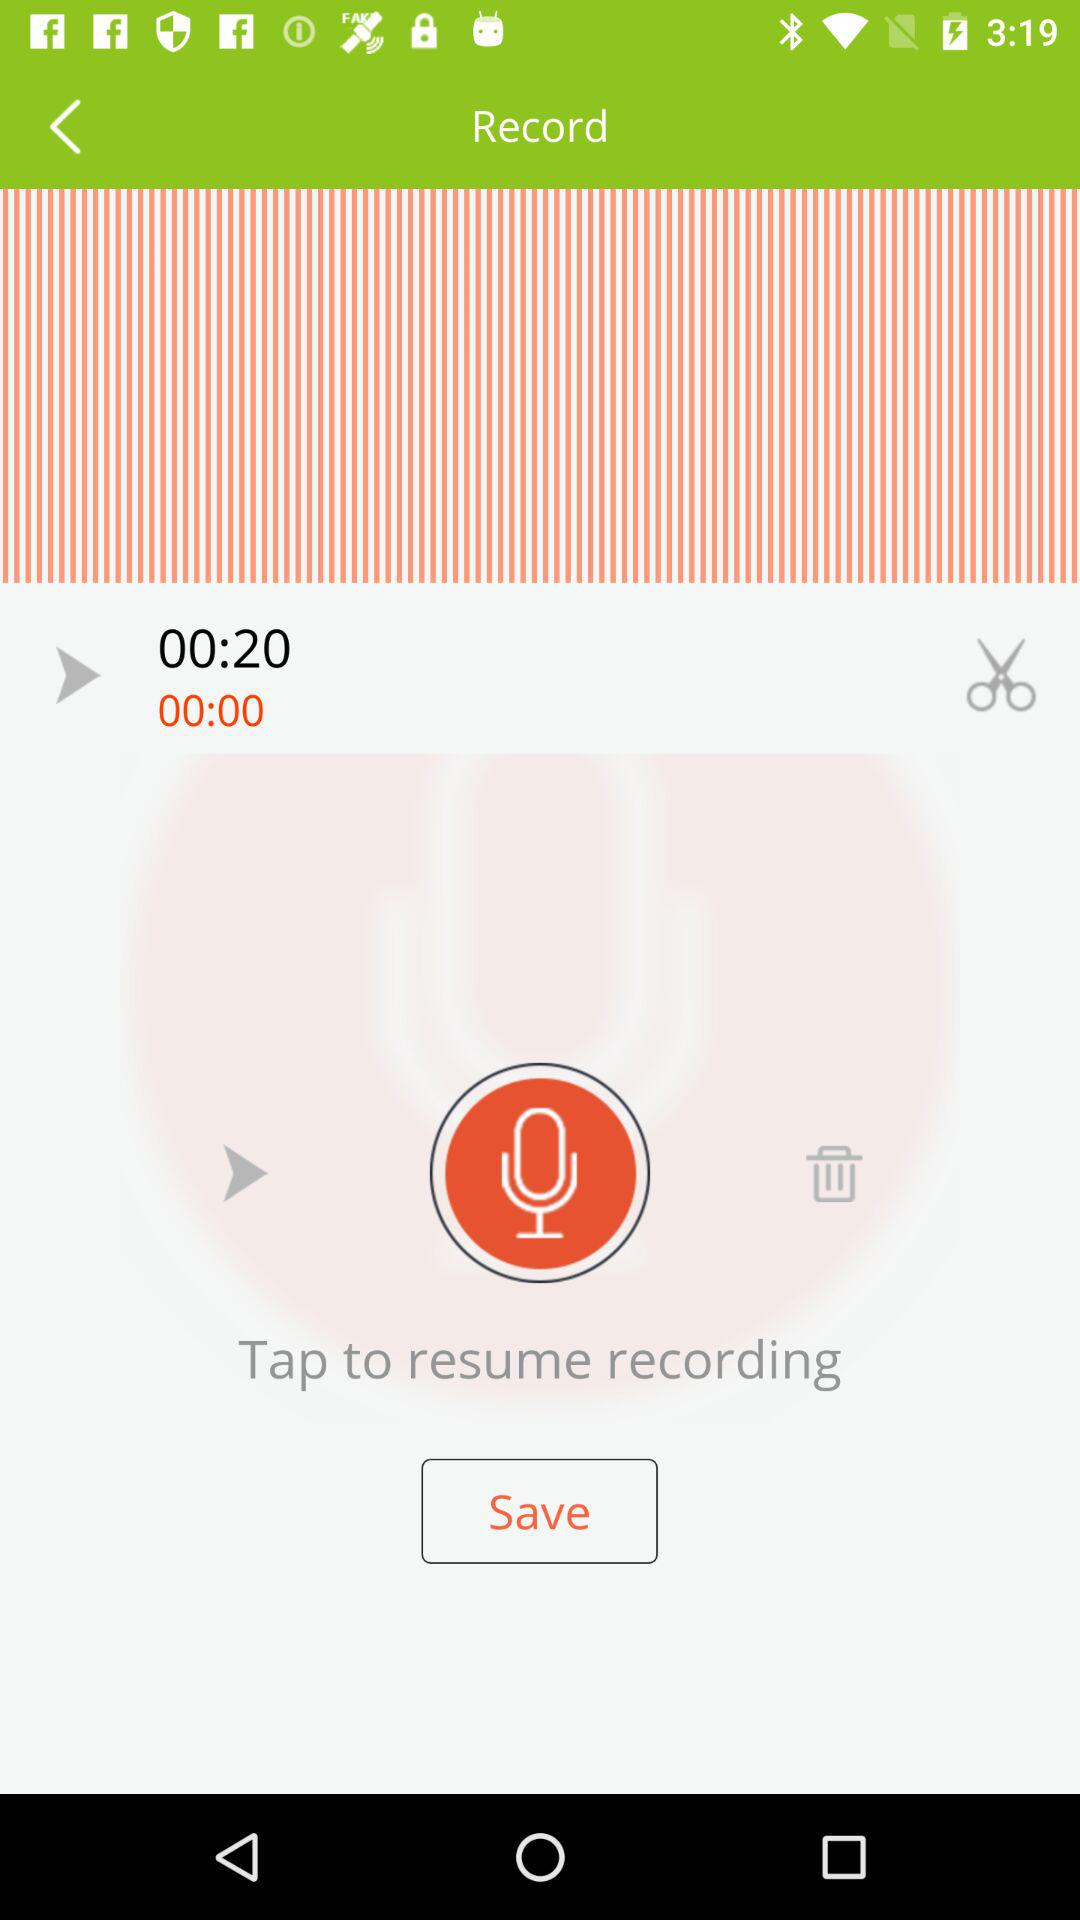What is the duration of the recording? The duration of the recording is 20 seconds. 